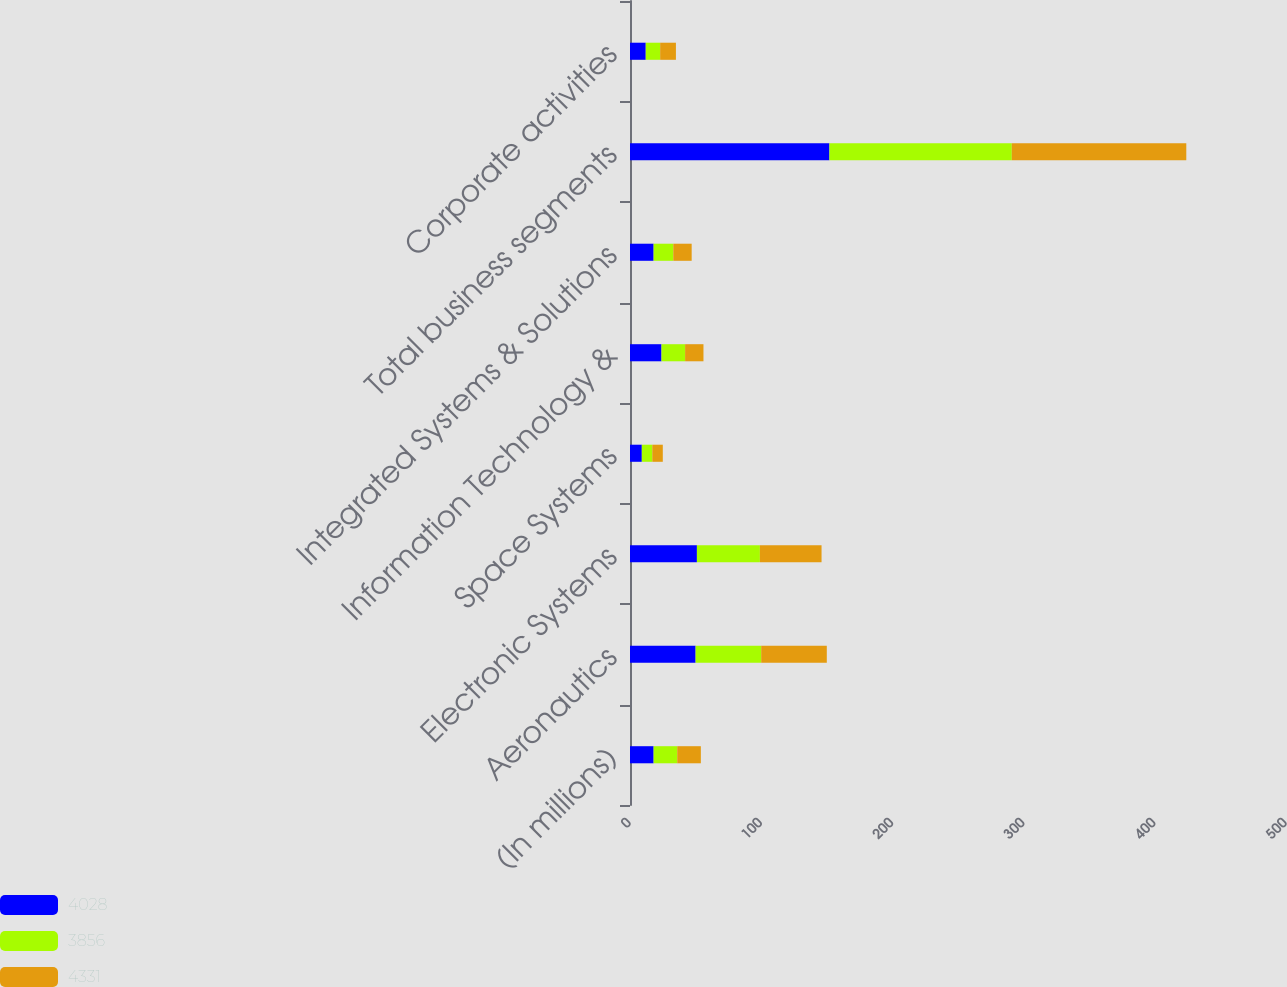Convert chart to OTSL. <chart><loc_0><loc_0><loc_500><loc_500><stacked_bar_chart><ecel><fcel>(In millions)<fcel>Aeronautics<fcel>Electronic Systems<fcel>Space Systems<fcel>Information Technology &<fcel>Integrated Systems & Solutions<fcel>Total business segments<fcel>Corporate activities<nl><fcel>4028<fcel>18<fcel>50<fcel>51<fcel>9<fcel>24<fcel>18<fcel>152<fcel>12<nl><fcel>3856<fcel>18<fcel>50<fcel>48<fcel>8<fcel>18<fcel>15<fcel>139<fcel>11<nl><fcel>4331<fcel>18<fcel>50<fcel>47<fcel>8<fcel>14<fcel>14<fcel>133<fcel>12<nl></chart> 